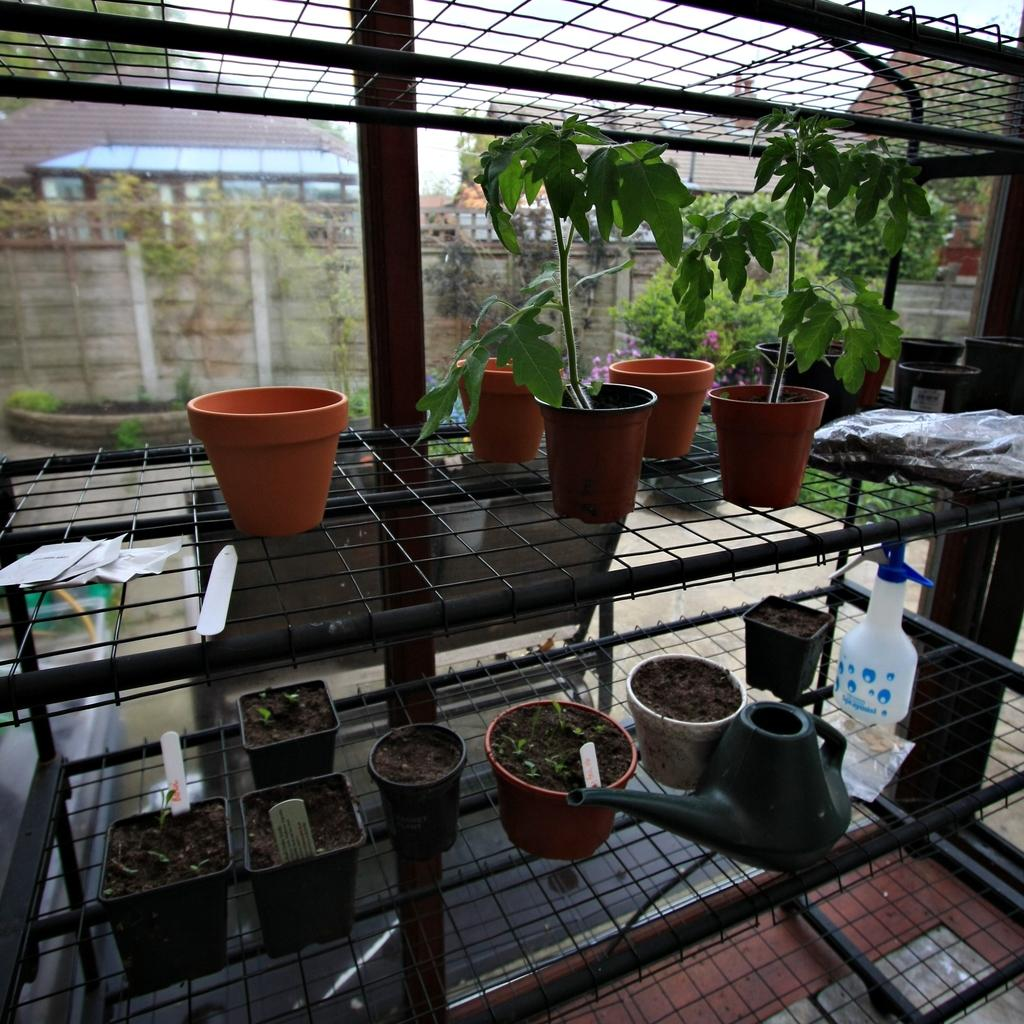What can be seen in the image that resembles vertical structures? There are posts in the image. What are the posts attached to or part of? The posts are on an object. What type of hat is being worn by the train in the image? There is no train or hat present in the image; it only features posts on an object. 